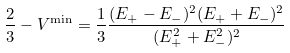Convert formula to latex. <formula><loc_0><loc_0><loc_500><loc_500>\frac { 2 } { 3 } - V ^ { \min } = \frac { 1 } { 3 } \frac { ( E _ { + } - E _ { - } ) ^ { 2 } ( E _ { + } + E _ { - } ) ^ { 2 } } { ( E _ { + } ^ { 2 } + E _ { - } ^ { 2 } ) ^ { 2 } }</formula> 